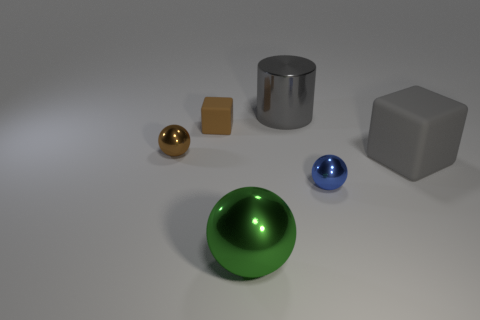What number of other things are the same shape as the gray matte thing?
Make the answer very short. 1. There is a large gray shiny thing; what shape is it?
Your response must be concise. Cylinder. How many tiny brown metal balls are in front of the metal thing that is in front of the tiny ball to the right of the small brown rubber object?
Your answer should be compact. 0. There is a big matte thing; does it have the same color as the big metallic object that is behind the blue object?
Ensure brevity in your answer.  Yes. There is a object that is the same color as the big cylinder; what shape is it?
Provide a short and direct response. Cube. There is a tiny sphere that is to the right of the big gray thing to the left of the small ball right of the gray cylinder; what is it made of?
Offer a very short reply. Metal. There is a large metallic thing that is in front of the big cylinder; does it have the same shape as the gray rubber thing?
Keep it short and to the point. No. There is a sphere that is on the right side of the big gray shiny cylinder; what is its material?
Offer a very short reply. Metal. How many metallic things are either large green things or big brown blocks?
Provide a short and direct response. 1. Is there a brown cylinder that has the same size as the brown rubber block?
Provide a succinct answer. No. 